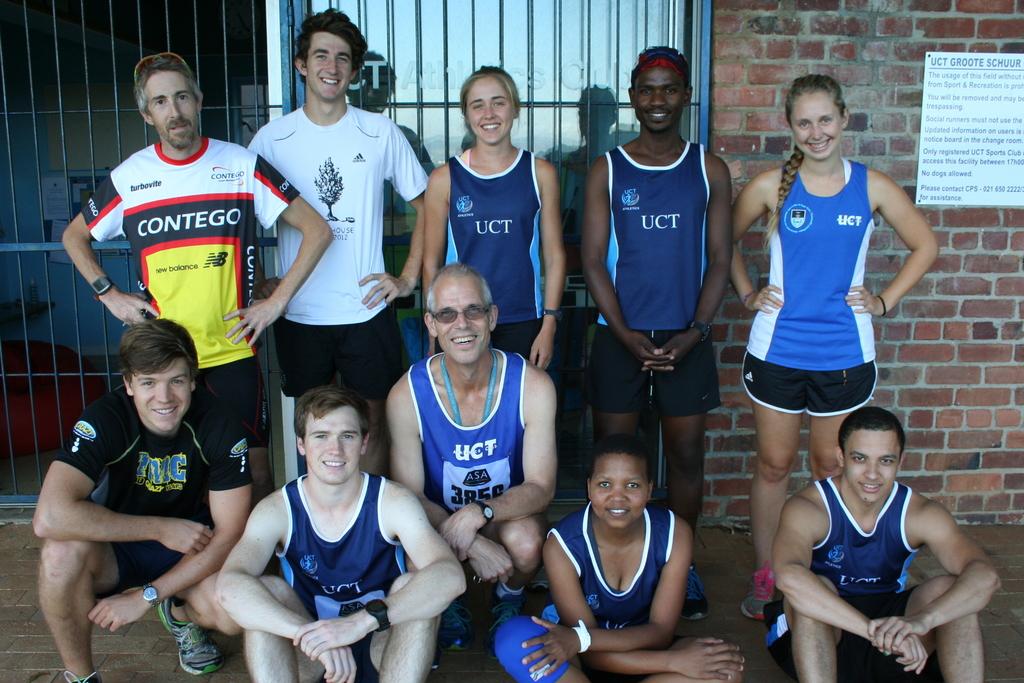What is on the guy on the rights shirt?
Your answer should be very brief. Uct. 